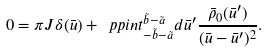Convert formula to latex. <formula><loc_0><loc_0><loc_500><loc_500>0 = \pi J \delta ( \bar { u } ) + \ p p i n t _ { - \tilde { b } - \tilde { a } } ^ { \tilde { b } - \tilde { a } } d \bar { u } ^ { \prime } \frac { \bar { \rho } _ { 0 } ( \bar { u } ^ { \prime } ) } { ( \bar { u } - \bar { u } ^ { \prime } ) ^ { 2 } } .</formula> 